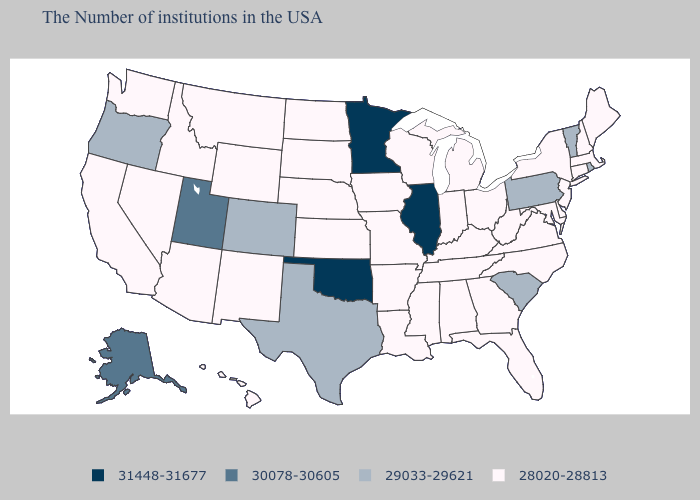Name the states that have a value in the range 31448-31677?
Answer briefly. Illinois, Minnesota, Oklahoma. Does North Carolina have the highest value in the USA?
Concise answer only. No. What is the value of Oregon?
Keep it brief. 29033-29621. Name the states that have a value in the range 29033-29621?
Answer briefly. Rhode Island, Vermont, Pennsylvania, South Carolina, Texas, Colorado, Oregon. What is the value of Alabama?
Give a very brief answer. 28020-28813. Name the states that have a value in the range 31448-31677?
Short answer required. Illinois, Minnesota, Oklahoma. Does Pennsylvania have the lowest value in the USA?
Give a very brief answer. No. Name the states that have a value in the range 31448-31677?
Give a very brief answer. Illinois, Minnesota, Oklahoma. How many symbols are there in the legend?
Concise answer only. 4. Does Oklahoma have the highest value in the South?
Quick response, please. Yes. What is the lowest value in the West?
Write a very short answer. 28020-28813. Name the states that have a value in the range 31448-31677?
Keep it brief. Illinois, Minnesota, Oklahoma. What is the value of Virginia?
Be succinct. 28020-28813. What is the value of Colorado?
Concise answer only. 29033-29621. 